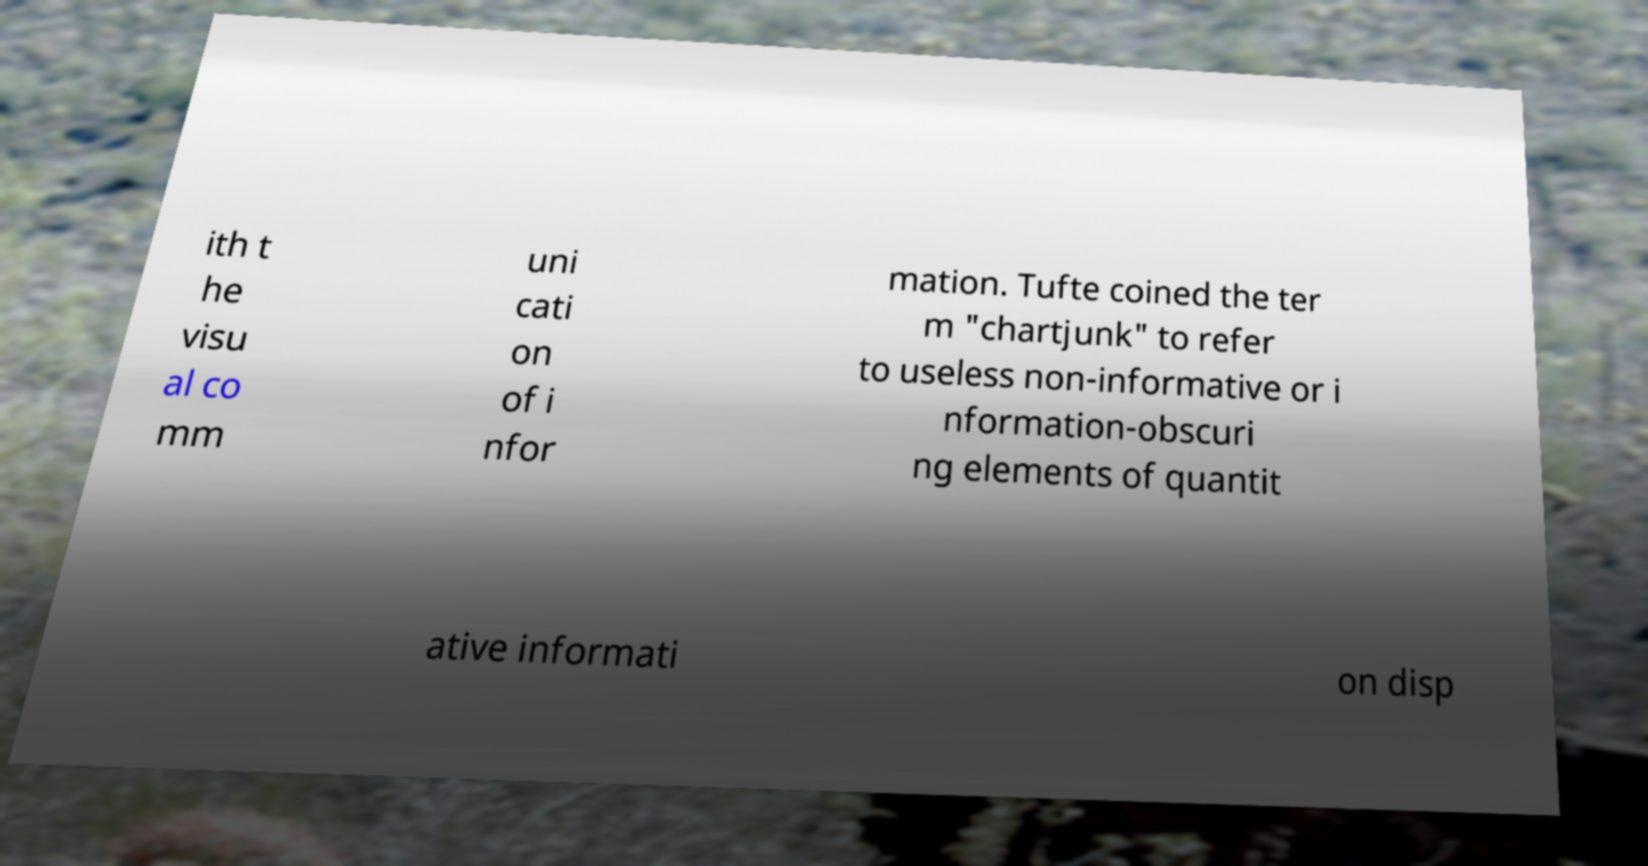Could you assist in decoding the text presented in this image and type it out clearly? ith t he visu al co mm uni cati on of i nfor mation. Tufte coined the ter m "chartjunk" to refer to useless non-informative or i nformation-obscuri ng elements of quantit ative informati on disp 